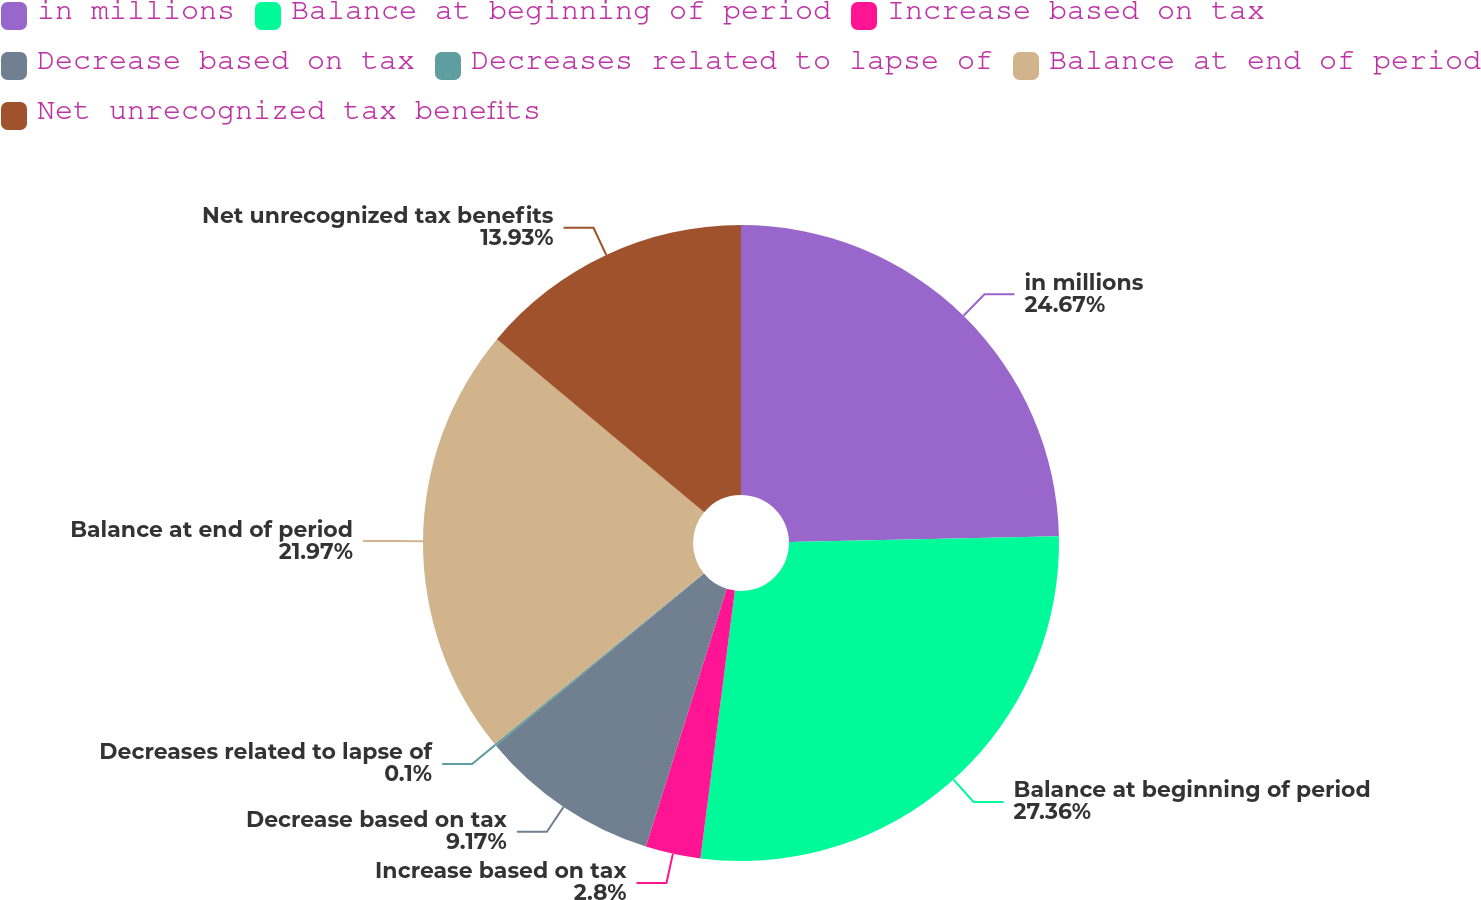Convert chart to OTSL. <chart><loc_0><loc_0><loc_500><loc_500><pie_chart><fcel>in millions<fcel>Balance at beginning of period<fcel>Increase based on tax<fcel>Decrease based on tax<fcel>Decreases related to lapse of<fcel>Balance at end of period<fcel>Net unrecognized tax benefits<nl><fcel>24.67%<fcel>27.37%<fcel>2.8%<fcel>9.17%<fcel>0.1%<fcel>21.97%<fcel>13.93%<nl></chart> 